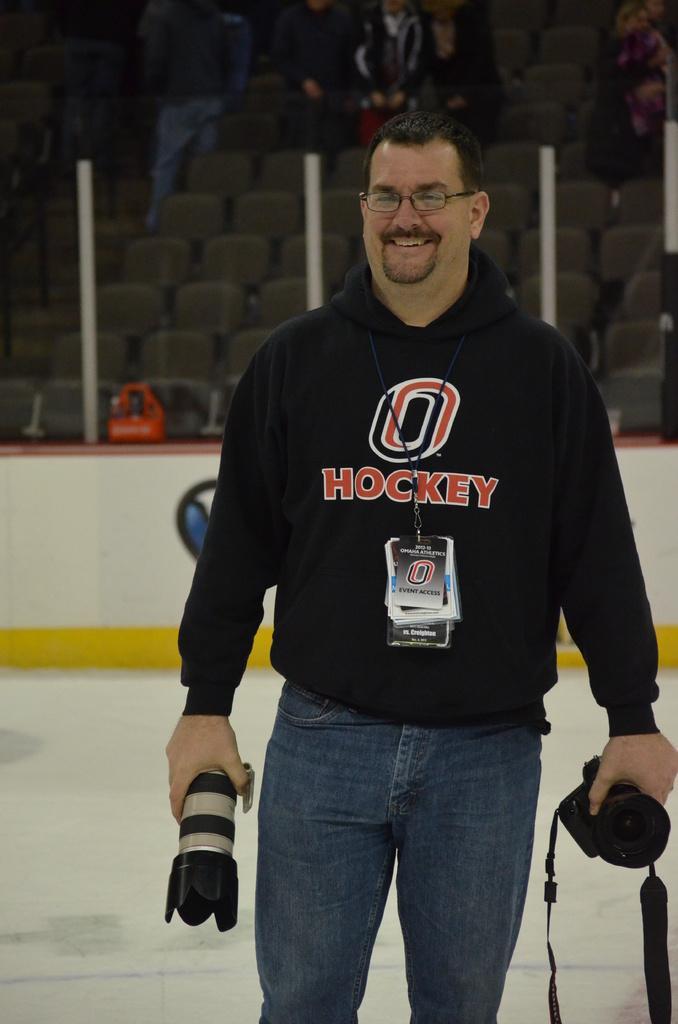Can you describe this image briefly? In the picture a person is wearing a black t-shirt and jeans and he is holding the camera in both his hands and behind him there are chairs and the people are sitting on them. 